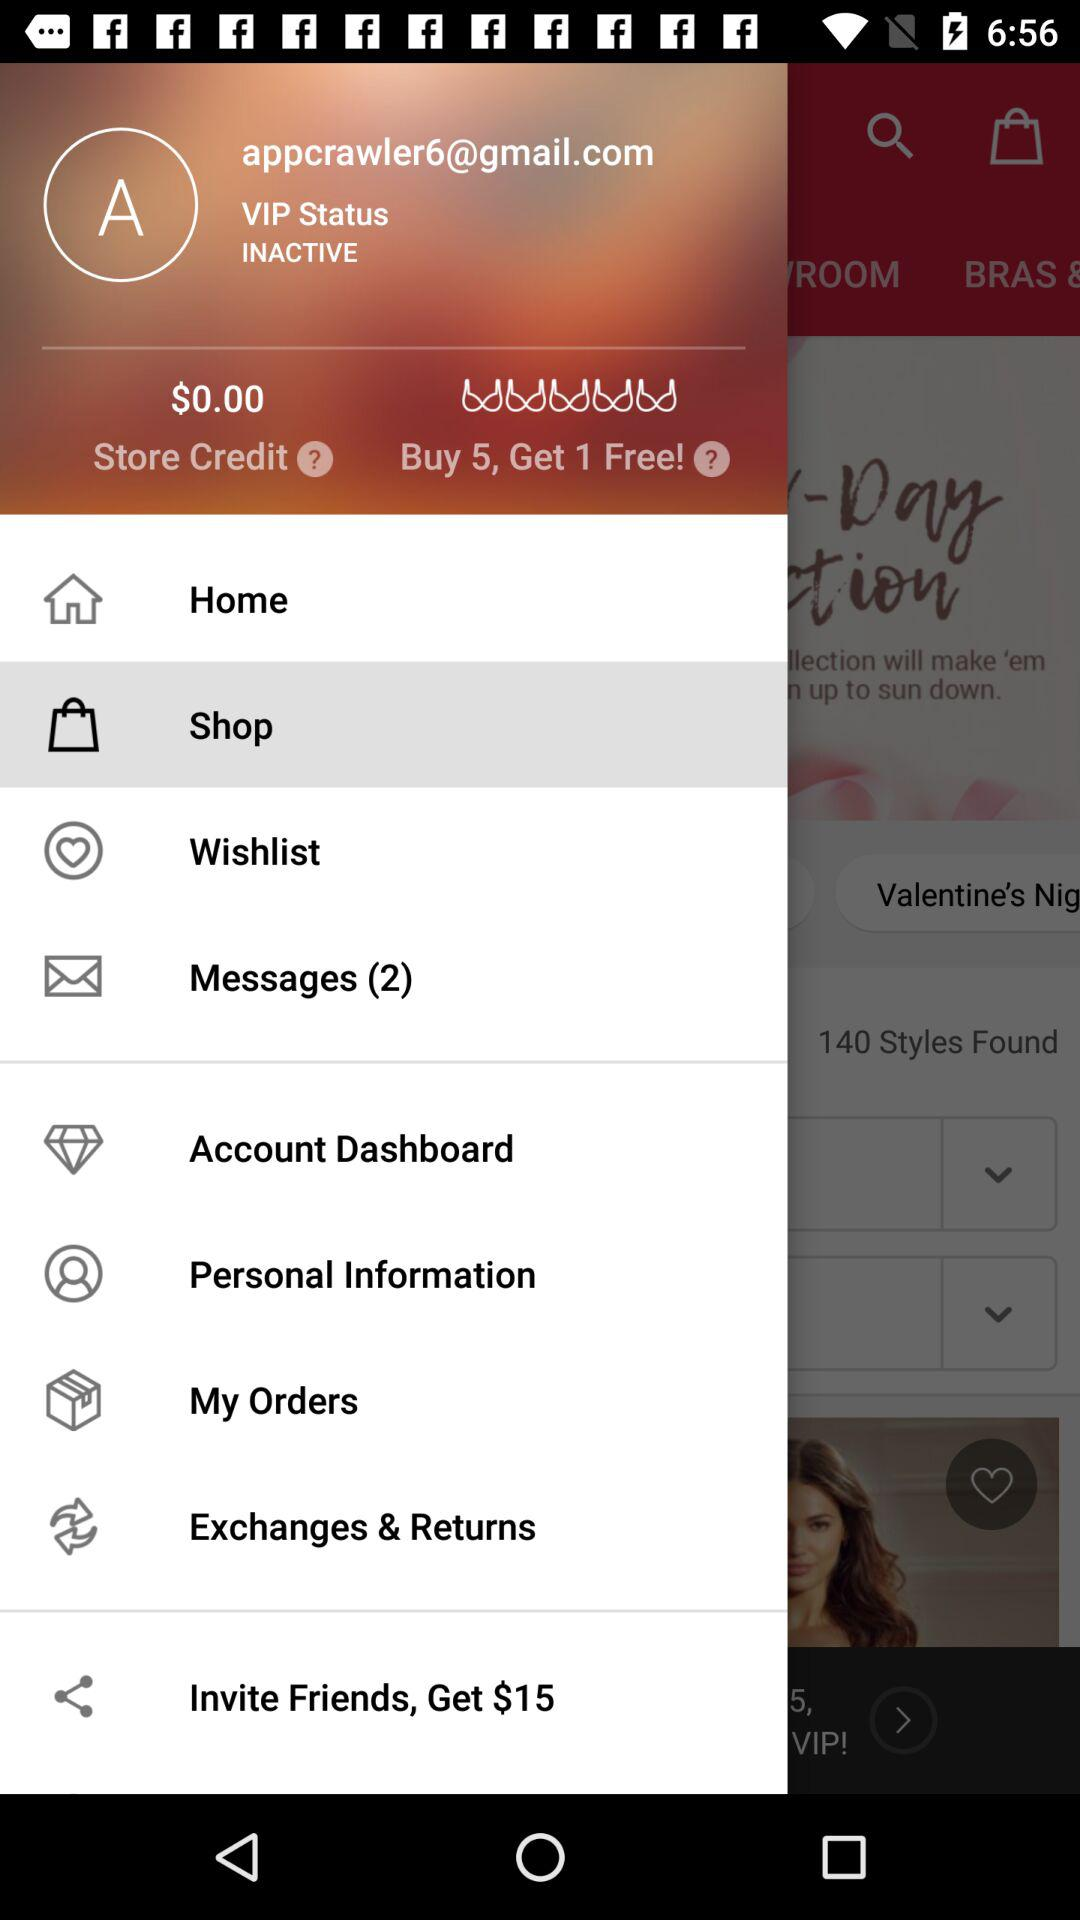What is the email address of a user? The email address of a user is "appcrawler6@gmail.com". 